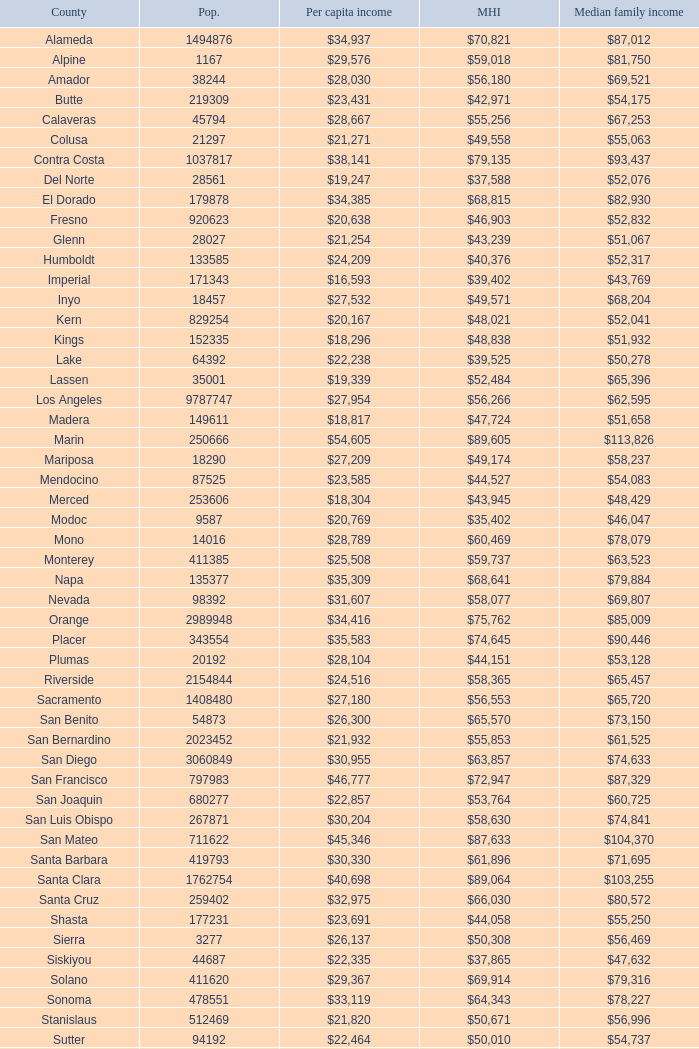What is the median household income of sacramento? $56,553. 